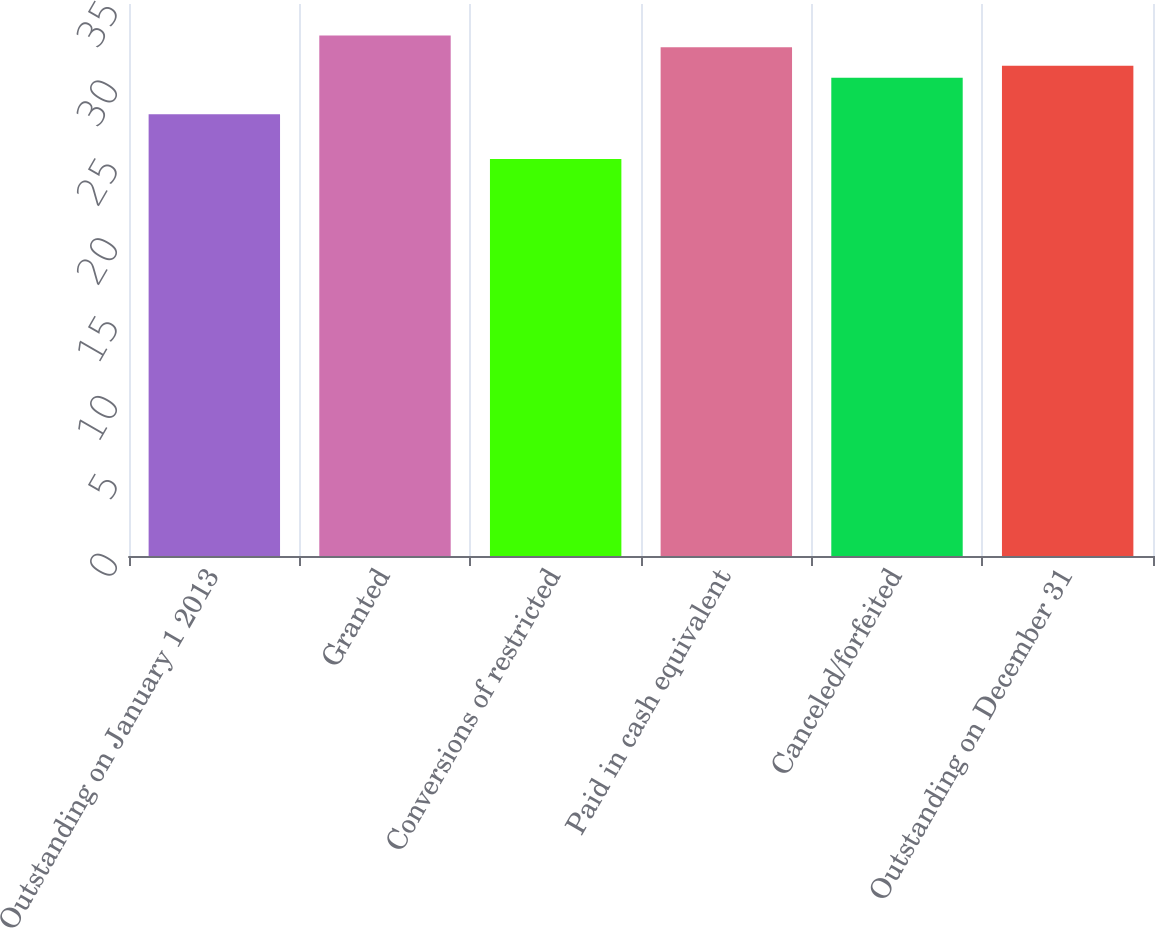Convert chart to OTSL. <chart><loc_0><loc_0><loc_500><loc_500><bar_chart><fcel>Outstanding on January 1 2013<fcel>Granted<fcel>Conversions of restricted<fcel>Paid in cash equivalent<fcel>Canceled/forfeited<fcel>Outstanding on December 31<nl><fcel>28.01<fcel>33<fcel>25.17<fcel>32.25<fcel>30.33<fcel>31.08<nl></chart> 